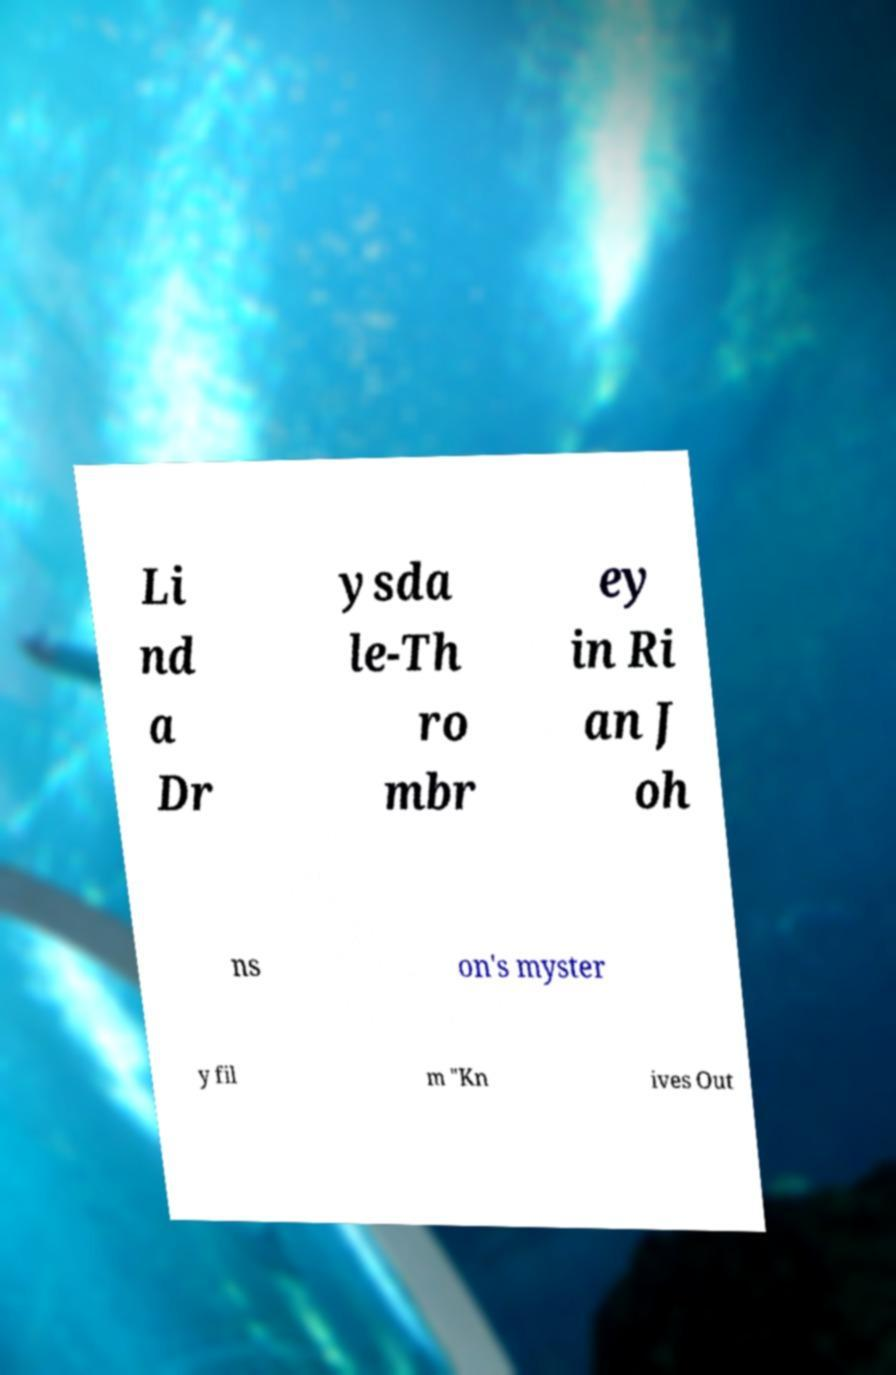I need the written content from this picture converted into text. Can you do that? Li nd a Dr ysda le-Th ro mbr ey in Ri an J oh ns on's myster y fil m "Kn ives Out 